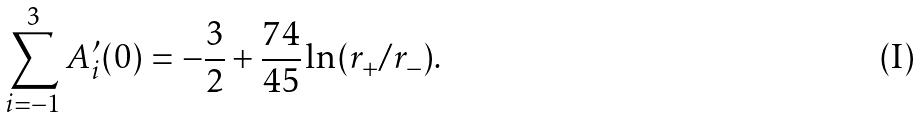Convert formula to latex. <formula><loc_0><loc_0><loc_500><loc_500>\sum _ { i = - 1 } ^ { 3 } A _ { i } ^ { \prime } ( 0 ) = - \frac { 3 } { 2 } + \frac { 7 4 } { 4 5 } \ln ( r _ { + } / r _ { - } ) .</formula> 